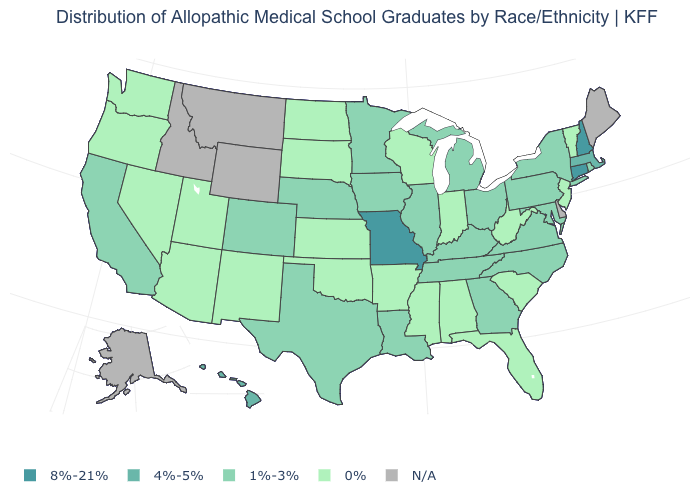Does the map have missing data?
Give a very brief answer. Yes. Which states hav the highest value in the MidWest?
Short answer required. Missouri. Is the legend a continuous bar?
Give a very brief answer. No. What is the value of California?
Answer briefly. 1%-3%. What is the value of Delaware?
Concise answer only. N/A. Which states have the highest value in the USA?
Write a very short answer. Connecticut, Missouri, New Hampshire. Is the legend a continuous bar?
Keep it brief. No. Name the states that have a value in the range 0%?
Write a very short answer. Alabama, Arizona, Arkansas, Florida, Indiana, Kansas, Mississippi, Nevada, New Jersey, New Mexico, North Dakota, Oklahoma, Oregon, South Carolina, South Dakota, Utah, Vermont, Washington, West Virginia, Wisconsin. Does the first symbol in the legend represent the smallest category?
Be succinct. No. What is the highest value in states that border Idaho?
Be succinct. 0%. Name the states that have a value in the range 0%?
Answer briefly. Alabama, Arizona, Arkansas, Florida, Indiana, Kansas, Mississippi, Nevada, New Jersey, New Mexico, North Dakota, Oklahoma, Oregon, South Carolina, South Dakota, Utah, Vermont, Washington, West Virginia, Wisconsin. What is the lowest value in the Northeast?
Give a very brief answer. 0%. Name the states that have a value in the range 4%-5%?
Give a very brief answer. Hawaii, Massachusetts. Name the states that have a value in the range 8%-21%?
Short answer required. Connecticut, Missouri, New Hampshire. 